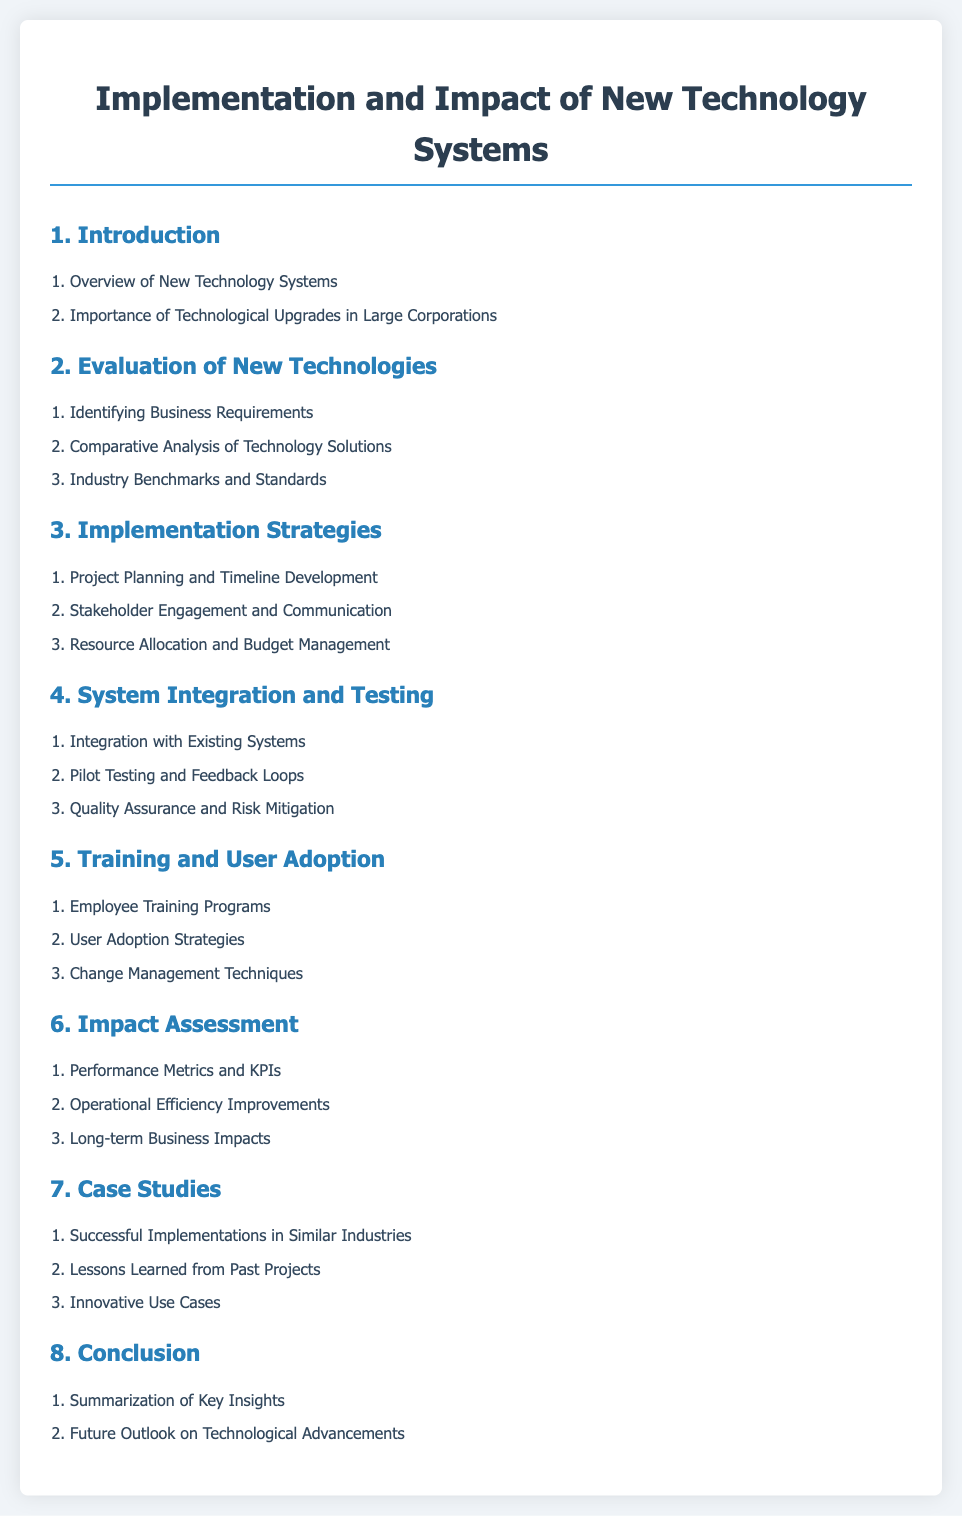What is the title of the document? The title is given at the top of the document within the main heading.
Answer: Implementation and Impact of New Technology Systems How many main sections are in the document? The document lists distinct main sections in the table of contents.
Answer: 8 What is the first topic under the Introduction section? The first topic is listed under the Introduction section in the table of contents.
Answer: Overview of New Technology Systems Which section includes “Employee Training Programs”? The section containing this topic is identified in the table of contents.
Answer: Training and User Adoption What is the last topic in the Case Studies section? The last topic is the final item listed under the Case Studies section.
Answer: Innovative Use Cases What is the focus of Section 6? This section's main theme is specified in the title of Section 6.
Answer: Impact Assessment Which two key areas are addressed in the Implementation Strategies section? This part is found in the items listed under the Implementation Strategies section.
Answer: Project Planning and Stakeholder Engagement What is one lesson mentioned in the Case Studies section? The lessons are derived from the topics listed in the Case Studies section of the document.
Answer: Lessons Learned from Past Projects 